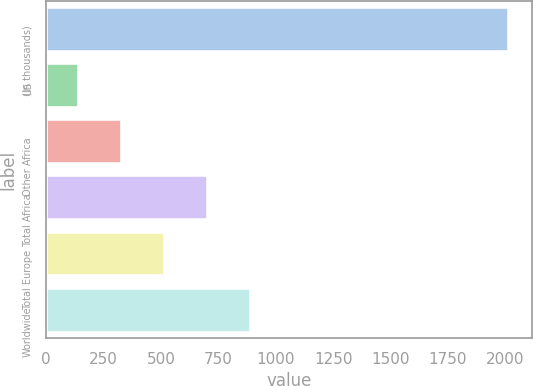Convert chart. <chart><loc_0><loc_0><loc_500><loc_500><bar_chart><fcel>(In thousands)<fcel>US<fcel>Other Africa<fcel>Total Africa<fcel>Total Europe<fcel>Worldwide<nl><fcel>2014<fcel>145<fcel>331.9<fcel>705.7<fcel>518.8<fcel>892.6<nl></chart> 